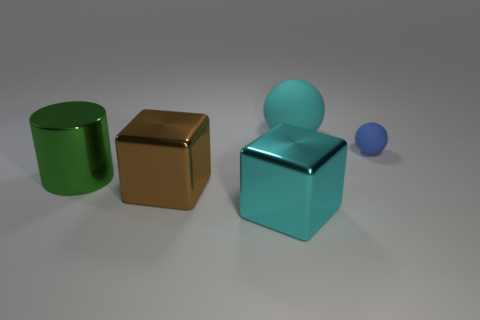The blue matte thing is what shape?
Make the answer very short. Sphere. The cyan thing to the left of the matte object on the left side of the blue rubber sphere is what shape?
Your answer should be very brief. Cube. Are the ball on the right side of the big rubber thing and the green thing made of the same material?
Make the answer very short. No. What number of cyan things are either shiny cylinders or small metallic cylinders?
Your answer should be compact. 0. Are there any other tiny objects of the same color as the small object?
Your answer should be very brief. No. Is there a small cube made of the same material as the green cylinder?
Make the answer very short. No. The large object that is both on the right side of the large cylinder and behind the brown metallic cube has what shape?
Give a very brief answer. Sphere. How many tiny things are cyan blocks or green rubber spheres?
Your answer should be very brief. 0. What is the material of the big brown thing?
Provide a succinct answer. Metal. How many other objects are there of the same shape as the large green object?
Offer a very short reply. 0. 